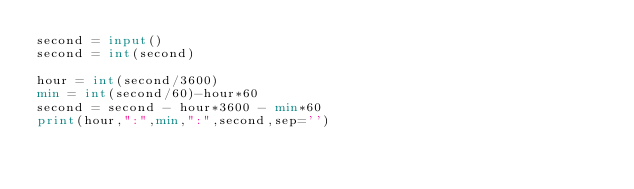Convert code to text. <code><loc_0><loc_0><loc_500><loc_500><_Python_>second = input()
second = int(second)

hour = int(second/3600)
min = int(second/60)-hour*60
second = second - hour*3600 - min*60
print(hour,":",min,":",second,sep='')
</code> 